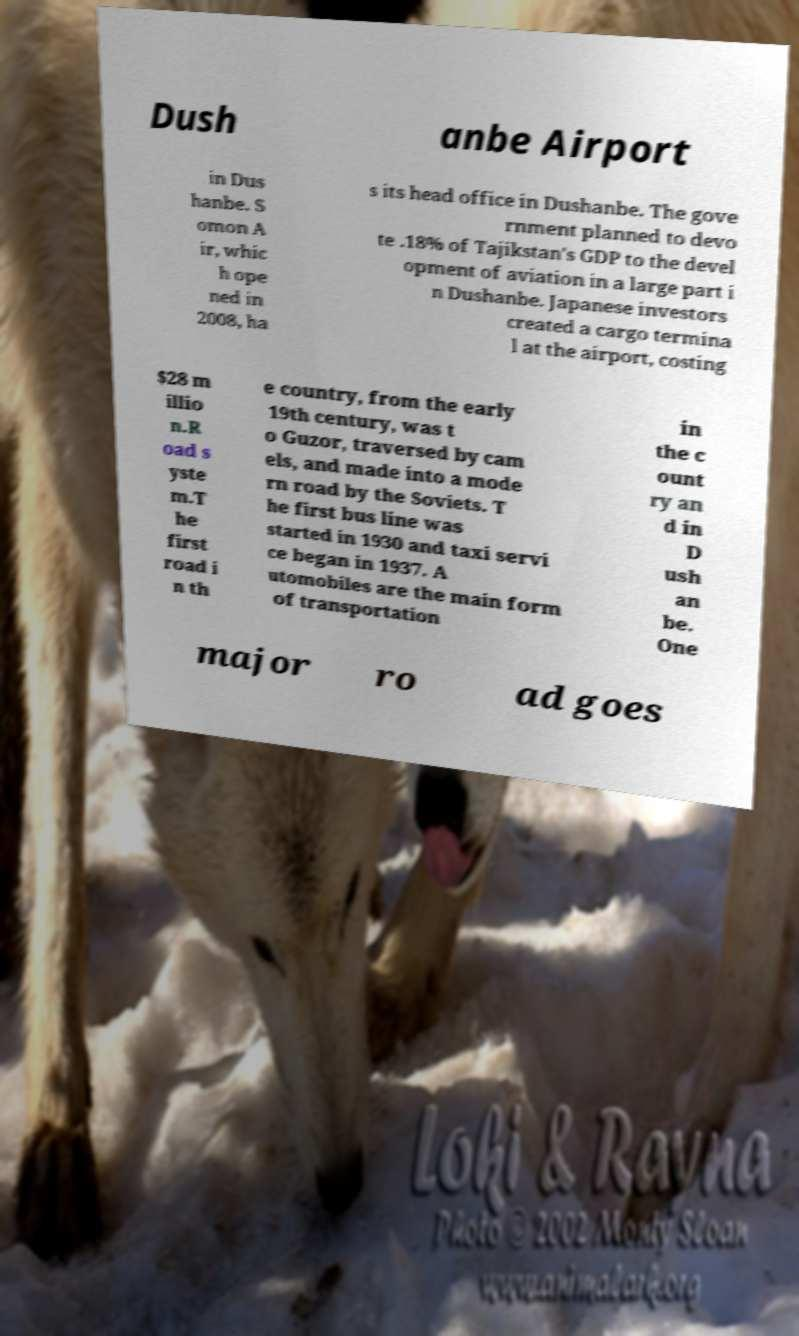Could you assist in decoding the text presented in this image and type it out clearly? Dush anbe Airport in Dus hanbe. S omon A ir, whic h ope ned in 2008, ha s its head office in Dushanbe. The gove rnment planned to devo te .18% of Tajikstan's GDP to the devel opment of aviation in a large part i n Dushanbe. Japanese investors created a cargo termina l at the airport, costing $28 m illio n.R oad s yste m.T he first road i n th e country, from the early 19th century, was t o Guzor, traversed by cam els, and made into a mode rn road by the Soviets. T he first bus line was started in 1930 and taxi servi ce began in 1937. A utomobiles are the main form of transportation in the c ount ry an d in D ush an be. One major ro ad goes 